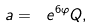Convert formula to latex. <formula><loc_0><loc_0><loc_500><loc_500>a = \ e ^ { 6 \varphi } Q ,</formula> 